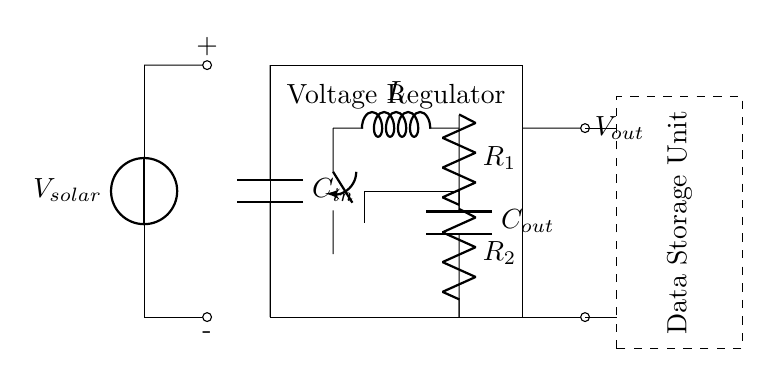What is the primary function of the voltage regulator in this circuit? The primary function of the voltage regulator is to maintain a consistent output voltage despite variations in input voltage from the solar panel.
Answer: Consistent output voltage What type of component is used for the input and output filtering? Capacitors are employed in both the input and output sections to smooth the voltage fluctuations and reduce noise.
Answer: Capacitors How many resistors are present in the feedback network? There are two resistors in the feedback network, which are part of the circuit's regulation mechanism.
Answer: Two resistors What does the dashed rectangle represent? The dashed rectangle symbolizes the data storage unit, indicating the load that the voltage regulator is powering.
Answer: Data storage unit What is the purpose of the inductor in this circuit? The inductor is used to store energy and smooth out current fluctuations, playing a critical role in the voltage regulation process.
Answer: Store energy What is the voltage source for this circuit? The circuit is powered by a solar panel, which provides the input voltage needed for the voltage regulator to function.
Answer: Solar panel How is the feedback network connected to the switching element? The feedback network connects to the switching element via a voltage-divider configuration, ensuring that the output voltage is used for regulation purposes.
Answer: Voltage-divider configuration 